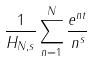<formula> <loc_0><loc_0><loc_500><loc_500>\frac { 1 } { H _ { N , s } } \sum _ { n = 1 } ^ { N } \frac { e ^ { n t } } { n ^ { s } }</formula> 